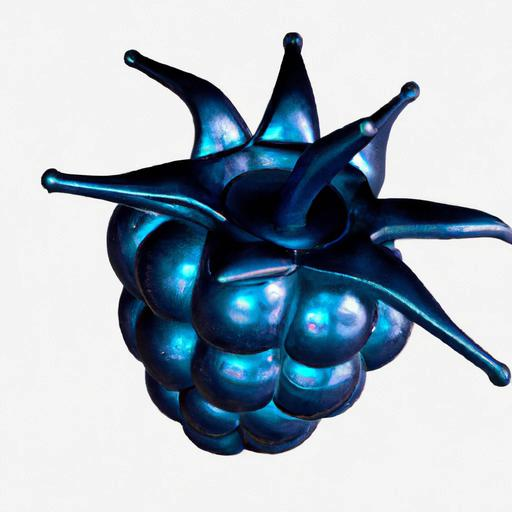Is the exposure accurate? The image seems to have balanced lighting with no areas overly bright or too dark, suggesting an accurate exposure that preserves detail across the subject. 